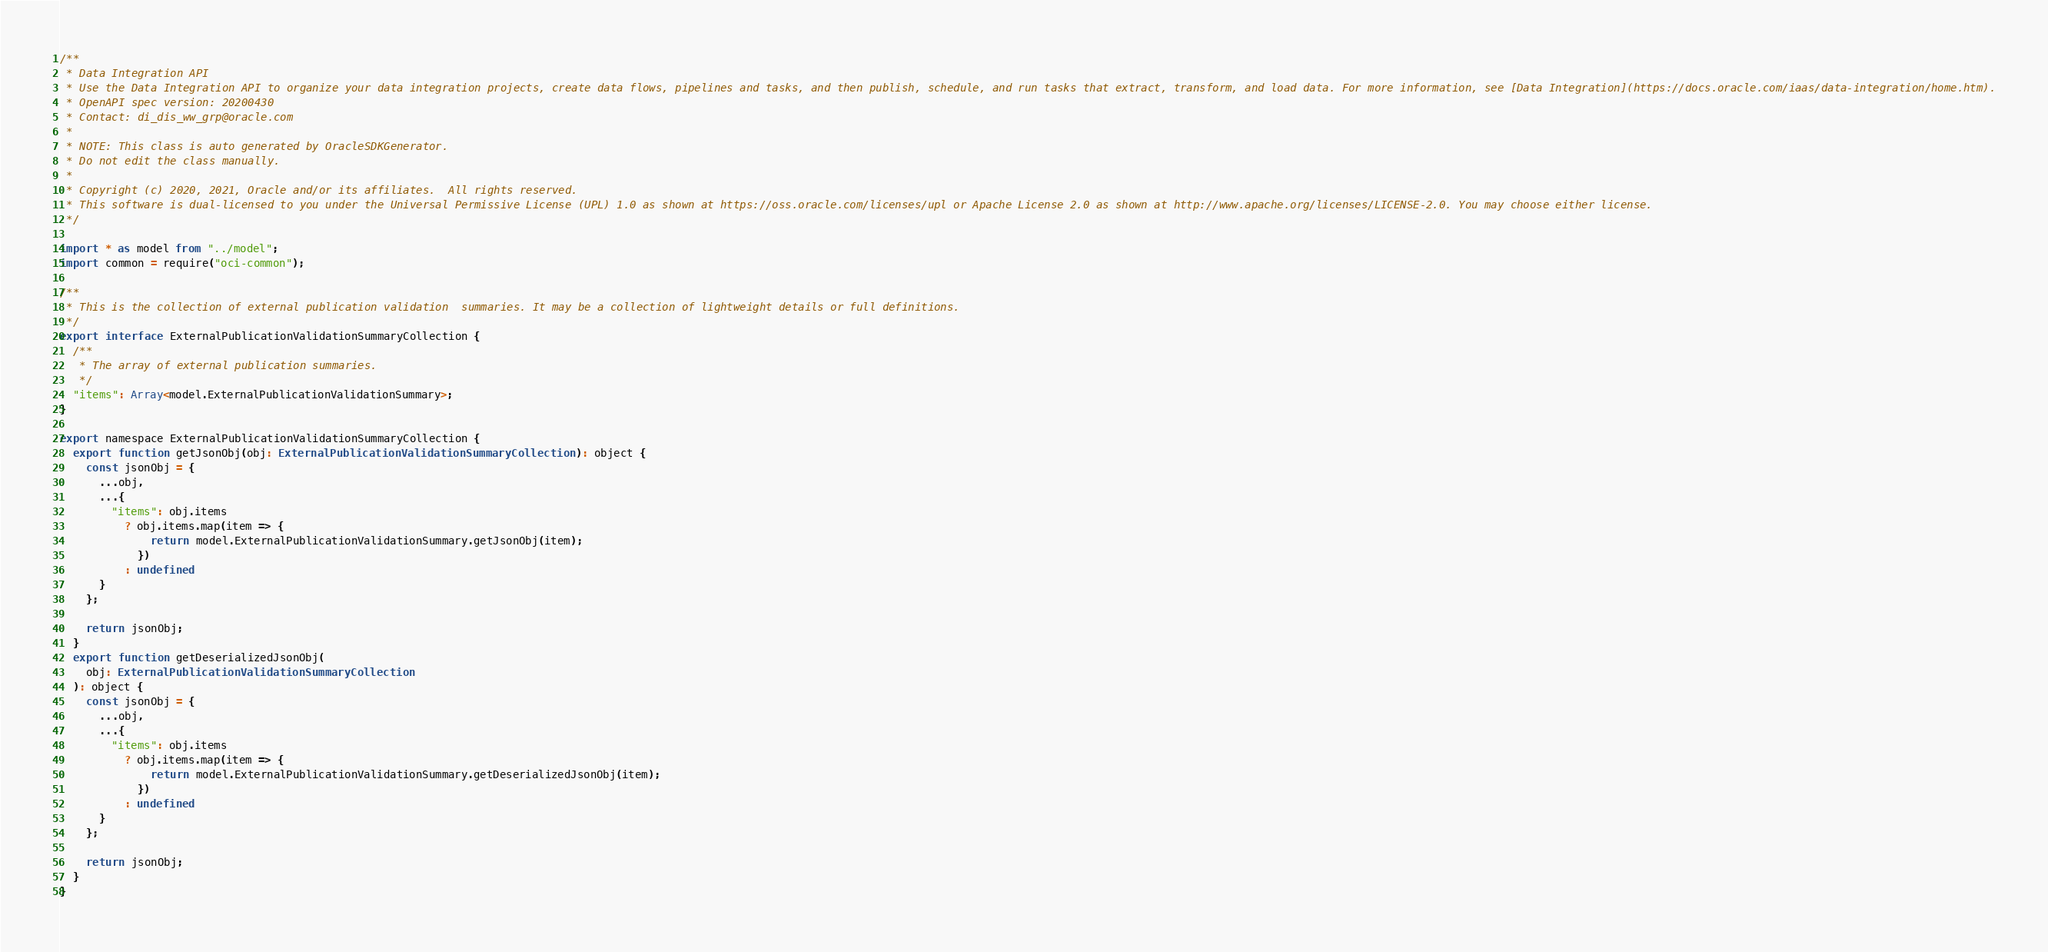<code> <loc_0><loc_0><loc_500><loc_500><_TypeScript_>/**
 * Data Integration API
 * Use the Data Integration API to organize your data integration projects, create data flows, pipelines and tasks, and then publish, schedule, and run tasks that extract, transform, and load data. For more information, see [Data Integration](https://docs.oracle.com/iaas/data-integration/home.htm).
 * OpenAPI spec version: 20200430
 * Contact: di_dis_ww_grp@oracle.com
 *
 * NOTE: This class is auto generated by OracleSDKGenerator.
 * Do not edit the class manually.
 *
 * Copyright (c) 2020, 2021, Oracle and/or its affiliates.  All rights reserved.
 * This software is dual-licensed to you under the Universal Permissive License (UPL) 1.0 as shown at https://oss.oracle.com/licenses/upl or Apache License 2.0 as shown at http://www.apache.org/licenses/LICENSE-2.0. You may choose either license.
 */

import * as model from "../model";
import common = require("oci-common");

/**
 * This is the collection of external publication validation  summaries. It may be a collection of lightweight details or full definitions.
 */
export interface ExternalPublicationValidationSummaryCollection {
  /**
   * The array of external publication summaries.
   */
  "items": Array<model.ExternalPublicationValidationSummary>;
}

export namespace ExternalPublicationValidationSummaryCollection {
  export function getJsonObj(obj: ExternalPublicationValidationSummaryCollection): object {
    const jsonObj = {
      ...obj,
      ...{
        "items": obj.items
          ? obj.items.map(item => {
              return model.ExternalPublicationValidationSummary.getJsonObj(item);
            })
          : undefined
      }
    };

    return jsonObj;
  }
  export function getDeserializedJsonObj(
    obj: ExternalPublicationValidationSummaryCollection
  ): object {
    const jsonObj = {
      ...obj,
      ...{
        "items": obj.items
          ? obj.items.map(item => {
              return model.ExternalPublicationValidationSummary.getDeserializedJsonObj(item);
            })
          : undefined
      }
    };

    return jsonObj;
  }
}
</code> 